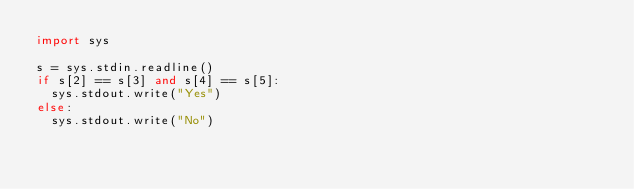<code> <loc_0><loc_0><loc_500><loc_500><_Python_>import sys

s = sys.stdin.readline()
if s[2] == s[3] and s[4] == s[5]:
  sys.stdout.write("Yes")
else:
  sys.stdout.write("No")</code> 